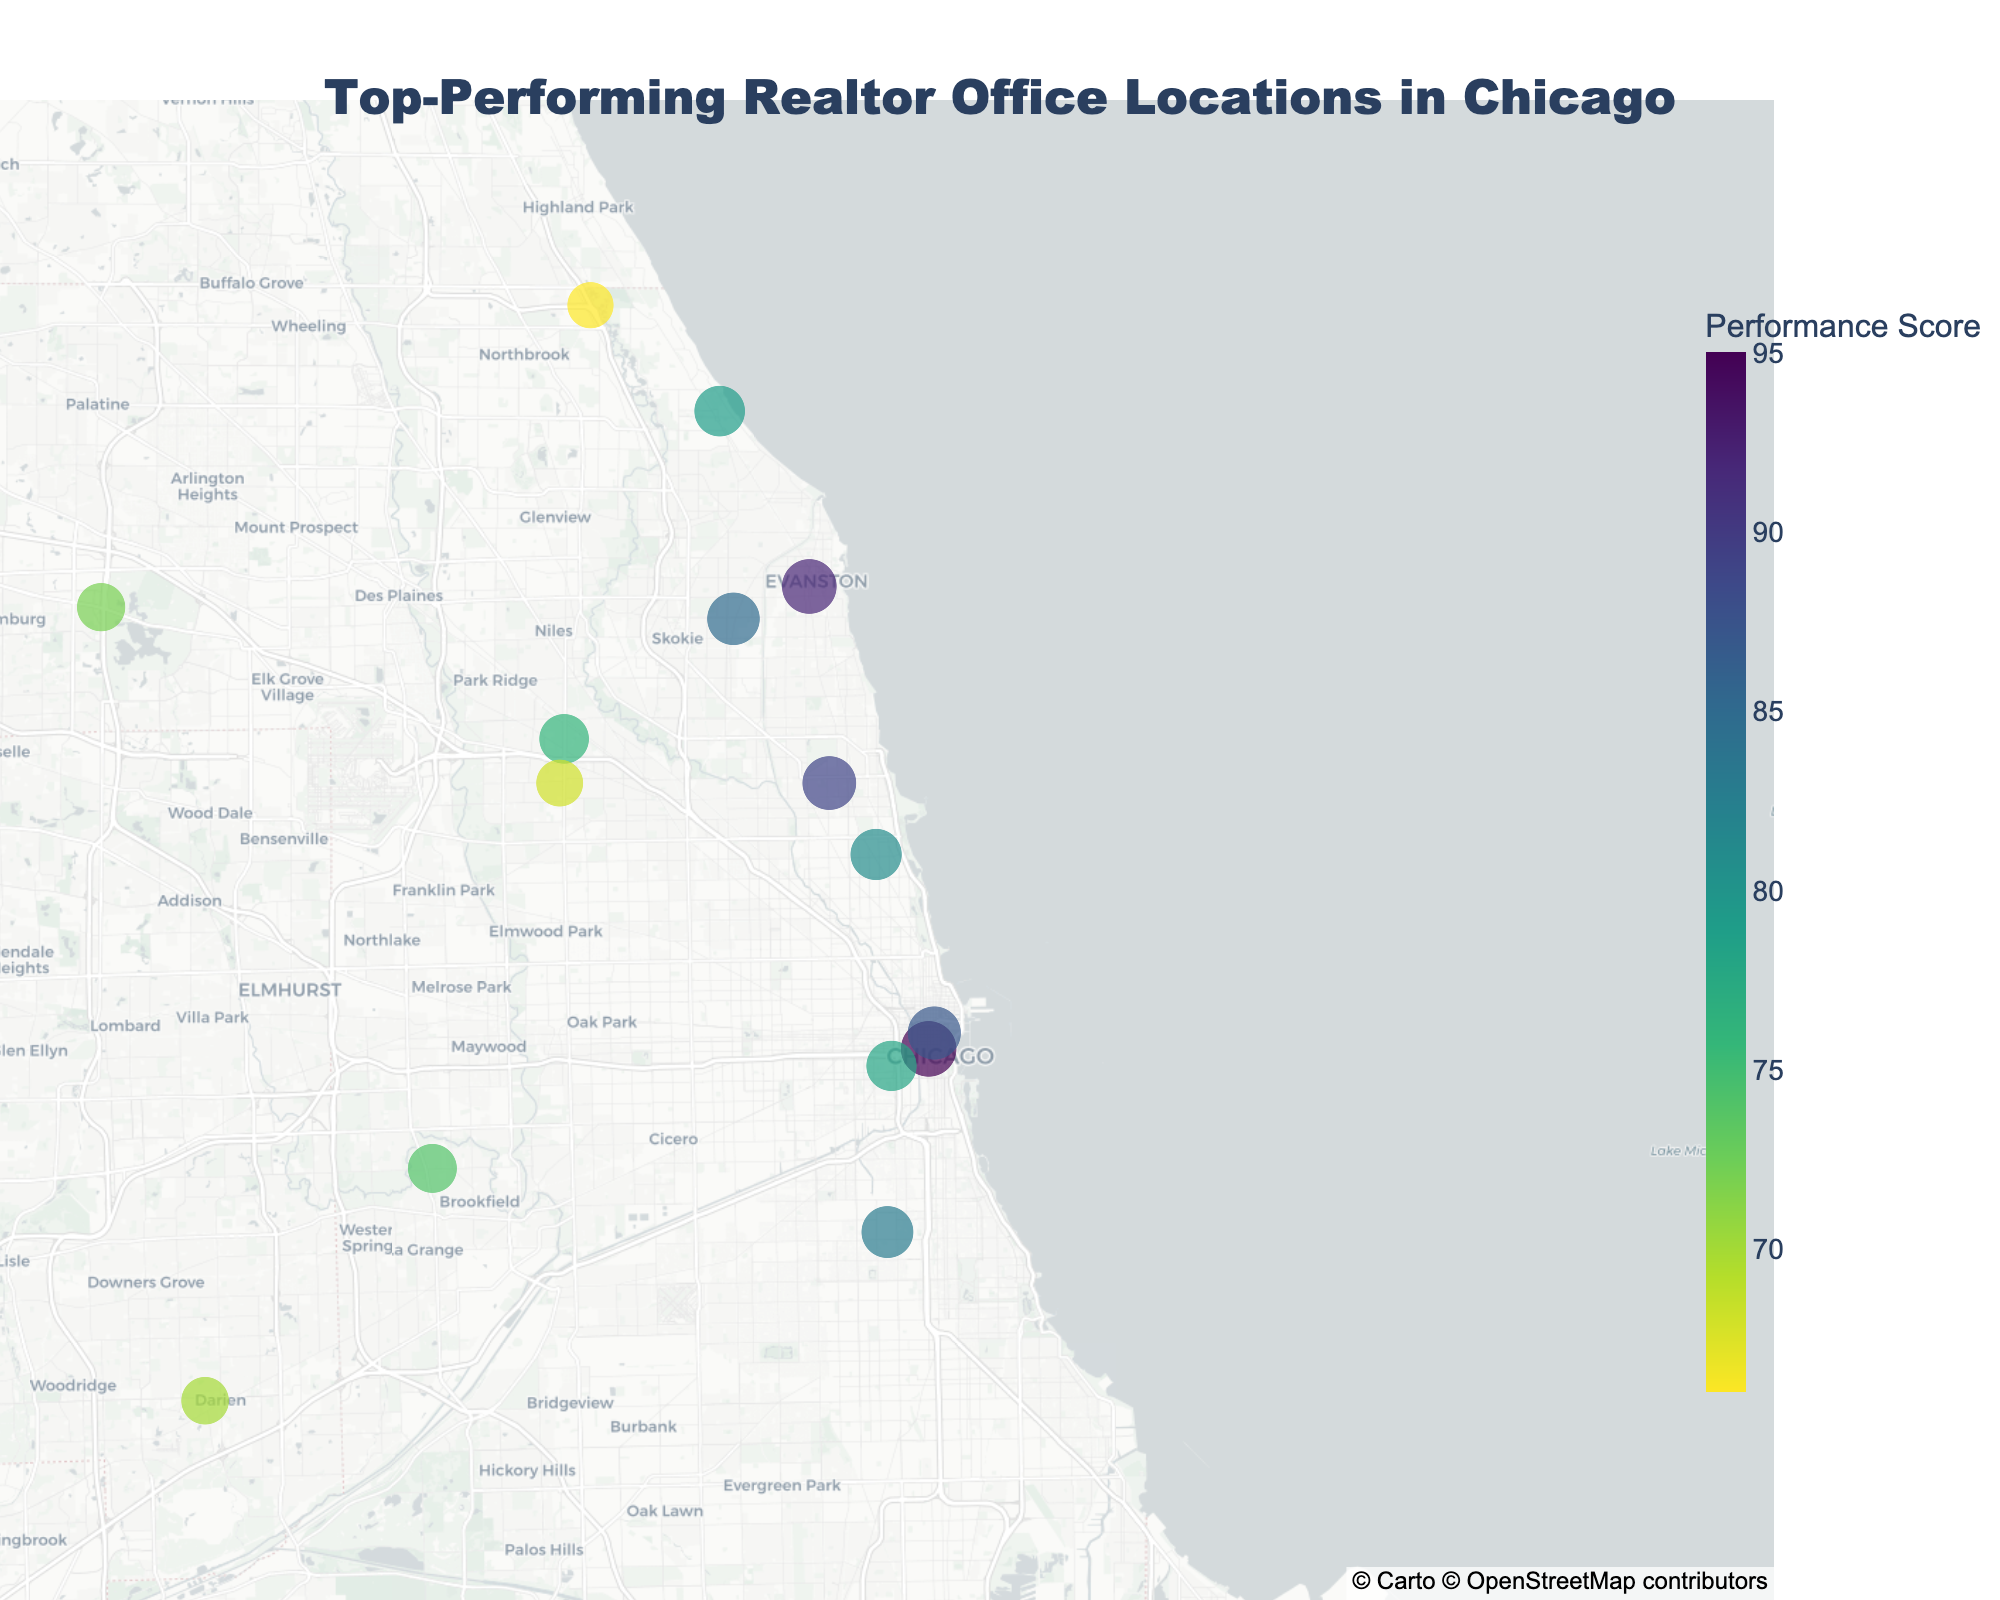How many top-performing realtor offices are visualized on the map? Count each individual data point representing a realtor office on the map.
Answer: 15 Which realtor office has the highest performance score? Identify the realtor office that has the darkest color representing the highest value on the color scale. @properties has the highest performance score of 95.
Answer: @properties What is the median performance score among the listed realtor offices? Arrange the performance scores in ascending order: 66, 68, 70, 72, 74, 76, 78, 79, 81, 83, 85, 87, 89, 92, 95. The middle value in the ordered list is 79, which is the median.
Answer: 79 Which realtor office is located furthest north on the map? Look for the realtor office with the highest latitude. Engel & Völkers Chicago, located at 42.1464 latitude, is the furthest north.
Answer: Engel & Völkers Chicago Are there more realtor offices located within Chicago city limits or in the surrounding suburbs? Examine the map and identify the clustering of data points. More offices appear to be concentrated within Chicago city limits based on the density of points around the central area of the map.
Answer: Within Chicago city limits Which realtor offices have a performance score greater than 80? Identify the data points with performance scores higher than 80. The offices are @properties, Coldwell Banker Realty, Compass, Berkshire Hathaway HomeServices, Baird & Warner, Dream Town Realty, and Jameson Sotheby's International Realty.
Answer: @properties, Coldwell Banker Realty, Compass, Berkshire Hathaway HomeServices, Baird & Warner, Dream Town Realty, Jameson Sotheby's International Realty Which realtor office is closest to the center of Chicago? The map’s center around Chicago is approximately at latitude 41.88 and longitude -87.63. Berkshire Hathaway HomeServices, located at 41.8839 latitude and -87.6270 longitude, is closest to these coordinates.
Answer: Berkshire Hathaway HomeServices What is the average performance score of all the top-performing realtor offices? Sum all performance scores and then divide by the number of data points: (95 + 92 + 89 + 87 + 85 + 83 + 81 + 79 + 78 + 76 + 74 + 72 + 70 + 68 + 66) / 15 = 79.4.
Answer: 79.4 How does the performance score distribution vary geographically? By observing the color intensity associated with the performance scores across different geographic locations on the map, note that higher performance scores are clustered in the central northern regions while lower scores are more dispersed.
Answer: Dense in central regions, more dispersed outskirts 